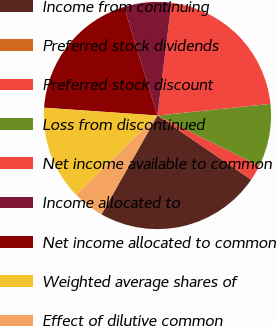<chart> <loc_0><loc_0><loc_500><loc_500><pie_chart><fcel>Income from continuing<fcel>Preferred stock dividends<fcel>Preferred stock discount<fcel>Loss from discontinued<fcel>Net income available to common<fcel>Income allocated to<fcel>Net income allocated to common<fcel>Weighted average shares of<fcel>Effect of dilutive common<nl><fcel>23.64%<fcel>0.0%<fcel>2.24%<fcel>8.95%<fcel>21.4%<fcel>6.71%<fcel>19.16%<fcel>13.42%<fcel>4.47%<nl></chart> 